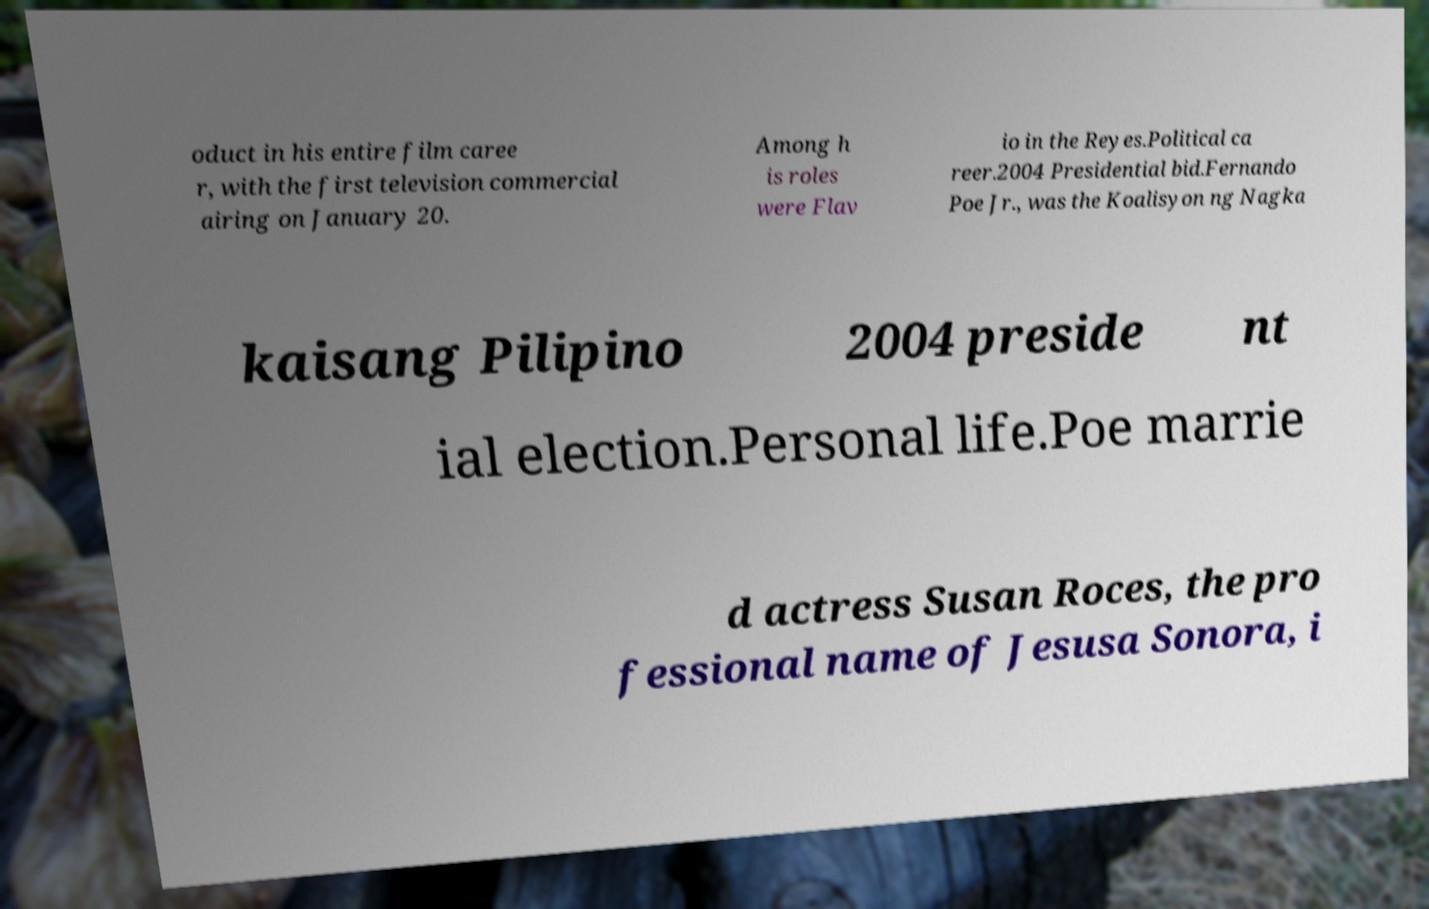There's text embedded in this image that I need extracted. Can you transcribe it verbatim? oduct in his entire film caree r, with the first television commercial airing on January 20. Among h is roles were Flav io in the Reyes.Political ca reer.2004 Presidential bid.Fernando Poe Jr., was the Koalisyon ng Nagka kaisang Pilipino 2004 preside nt ial election.Personal life.Poe marrie d actress Susan Roces, the pro fessional name of Jesusa Sonora, i 